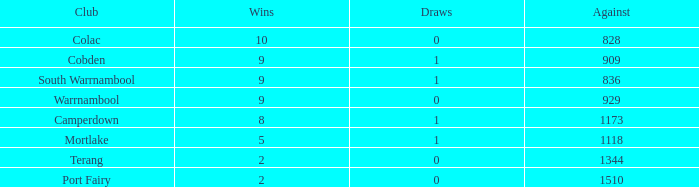What is the typical quantity of draws for losses greater than 8 and against values less than 1344? None. 